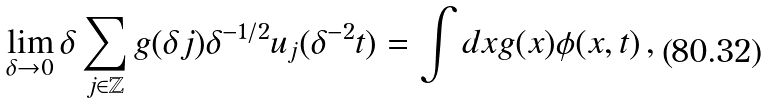Convert formula to latex. <formula><loc_0><loc_0><loc_500><loc_500>\lim _ { \delta \to 0 } \delta \sum _ { j \in \mathbb { Z } } g ( \delta j ) \delta ^ { - 1 / 2 } u _ { j } ( \delta ^ { - 2 } t ) = \int d x g ( x ) \phi ( x , t ) \, ,</formula> 